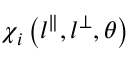Convert formula to latex. <formula><loc_0><loc_0><loc_500><loc_500>\chi _ { i } \left ( l ^ { \| } , l ^ { \perp } , \theta \right )</formula> 